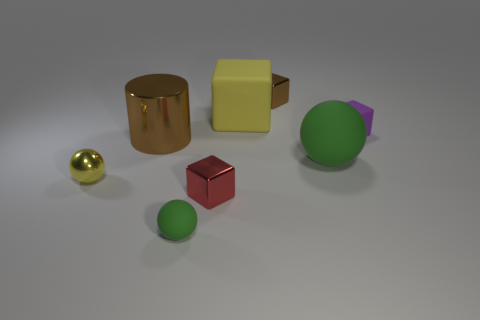Add 1 large green objects. How many objects exist? 9 Subtract all cylinders. How many objects are left? 7 Add 5 tiny matte cubes. How many tiny matte cubes exist? 6 Subtract 1 red cubes. How many objects are left? 7 Subtract all small cyan objects. Subtract all red metallic blocks. How many objects are left? 7 Add 6 tiny red objects. How many tiny red objects are left? 7 